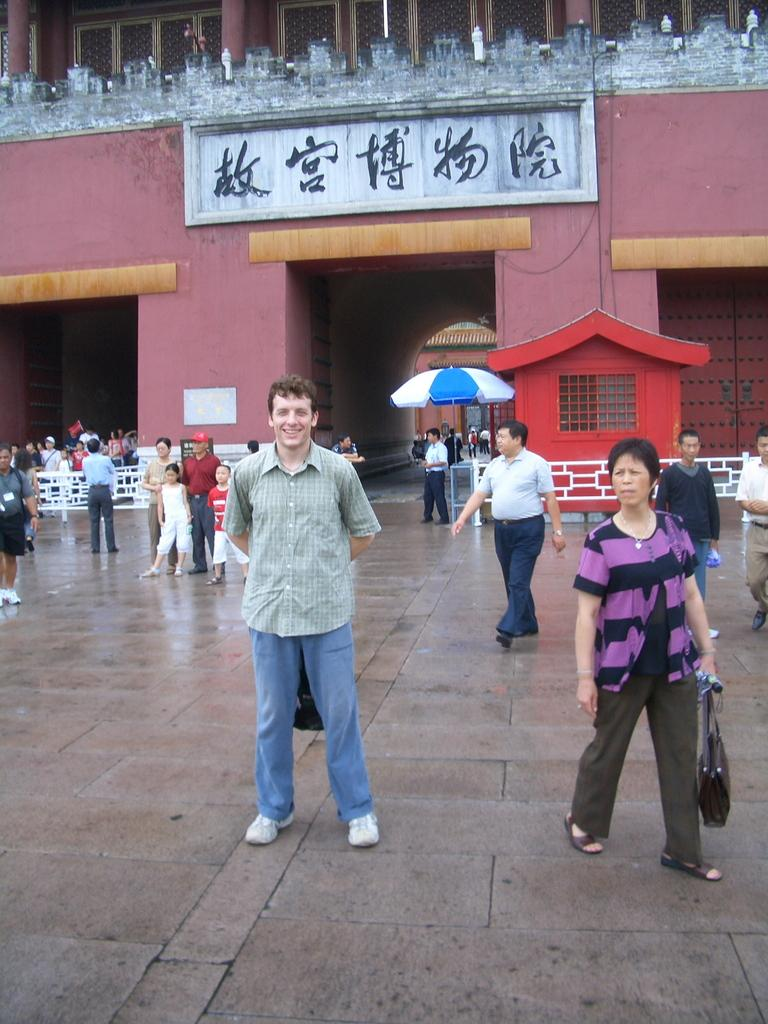What is the main structure visible in the image? There is a building with a name board in the image. What is happening in front of the building? There are people standing and walking in front of the building. What type of barrier is present in the image? There is a fence in the image. What object is used for protection from the rain in the image? There is an umbrella in the image. What type of ink is being used by the people in the image? There is no indication in the image that people are using ink. --- Facts: 1. There is a person holding a book in the image. 2. The person is sitting on a chair. 3. There is a table in the image. 4. The table has a lamp on it. 5. There is a window in the background. Absurd Topics: dance, ocean, bird Conversation: What is the person in the image holding? The person is holding a book in the image. What is the person sitting on? The person is sitting on a chair. What object is present on the table in the image? The table has a lamp on it. What can be seen in the background of the image? There is a window in the background. Reasoning: Let's think step by step in order to produce the conversation. We start by identifying the main subject in the image, which is the person holding a book. Then, we describe the person's position and the presence of a chair. Next, we mention the table and the lamp on it. Finally, we identify the window in the background. Absurd Question/Answer: What type of dance is being performed by the bird in the image? There is no bird present in the image, and therefore no dance can be observed. 